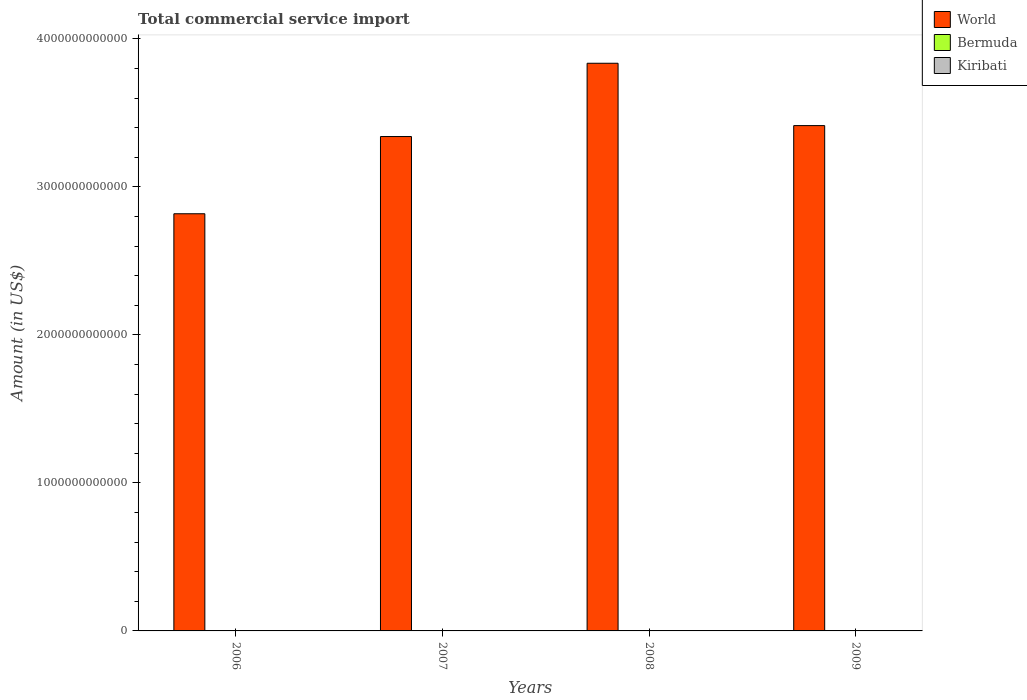How many different coloured bars are there?
Make the answer very short. 3. Are the number of bars on each tick of the X-axis equal?
Keep it short and to the point. Yes. How many bars are there on the 2nd tick from the right?
Offer a terse response. 3. What is the label of the 4th group of bars from the left?
Your response must be concise. 2009. What is the total commercial service import in Kiribati in 2009?
Give a very brief answer. 4.27e+07. Across all years, what is the maximum total commercial service import in World?
Provide a short and direct response. 3.83e+12. Across all years, what is the minimum total commercial service import in World?
Provide a succinct answer. 2.82e+12. What is the total total commercial service import in Bermuda in the graph?
Ensure brevity in your answer.  3.91e+09. What is the difference between the total commercial service import in Bermuda in 2007 and that in 2009?
Offer a very short reply. 1.24e+08. What is the difference between the total commercial service import in World in 2008 and the total commercial service import in Kiribati in 2006?
Offer a terse response. 3.83e+12. What is the average total commercial service import in Kiribati per year?
Provide a short and direct response. 4.04e+07. In the year 2008, what is the difference between the total commercial service import in Bermuda and total commercial service import in World?
Provide a succinct answer. -3.83e+12. What is the ratio of the total commercial service import in Bermuda in 2006 to that in 2008?
Make the answer very short. 0.82. Is the total commercial service import in Kiribati in 2007 less than that in 2009?
Ensure brevity in your answer.  Yes. Is the difference between the total commercial service import in Bermuda in 2006 and 2009 greater than the difference between the total commercial service import in World in 2006 and 2009?
Keep it short and to the point. Yes. What is the difference between the highest and the second highest total commercial service import in World?
Provide a succinct answer. 4.21e+11. What is the difference between the highest and the lowest total commercial service import in World?
Provide a succinct answer. 1.02e+12. In how many years, is the total commercial service import in World greater than the average total commercial service import in World taken over all years?
Keep it short and to the point. 2. Is the sum of the total commercial service import in World in 2007 and 2009 greater than the maximum total commercial service import in Kiribati across all years?
Your answer should be very brief. Yes. What does the 1st bar from the left in 2006 represents?
Your answer should be compact. World. What does the 1st bar from the right in 2007 represents?
Make the answer very short. Kiribati. Is it the case that in every year, the sum of the total commercial service import in Bermuda and total commercial service import in World is greater than the total commercial service import in Kiribati?
Your answer should be compact. Yes. Are all the bars in the graph horizontal?
Your answer should be compact. No. How many years are there in the graph?
Give a very brief answer. 4. What is the difference between two consecutive major ticks on the Y-axis?
Make the answer very short. 1.00e+12. Are the values on the major ticks of Y-axis written in scientific E-notation?
Your answer should be compact. No. Does the graph contain grids?
Offer a very short reply. No. How are the legend labels stacked?
Give a very brief answer. Vertical. What is the title of the graph?
Your answer should be very brief. Total commercial service import. Does "Vanuatu" appear as one of the legend labels in the graph?
Offer a very short reply. No. What is the Amount (in US$) in World in 2006?
Keep it short and to the point. 2.82e+12. What is the Amount (in US$) of Bermuda in 2006?
Provide a short and direct response. 8.37e+08. What is the Amount (in US$) in Kiribati in 2006?
Your answer should be very brief. 3.01e+07. What is the Amount (in US$) of World in 2007?
Ensure brevity in your answer.  3.34e+12. What is the Amount (in US$) of Bermuda in 2007?
Offer a terse response. 1.09e+09. What is the Amount (in US$) of Kiribati in 2007?
Provide a succinct answer. 4.14e+07. What is the Amount (in US$) of World in 2008?
Give a very brief answer. 3.83e+12. What is the Amount (in US$) of Bermuda in 2008?
Provide a succinct answer. 1.02e+09. What is the Amount (in US$) in Kiribati in 2008?
Provide a short and direct response. 4.74e+07. What is the Amount (in US$) of World in 2009?
Offer a very short reply. 3.41e+12. What is the Amount (in US$) in Bermuda in 2009?
Make the answer very short. 9.66e+08. What is the Amount (in US$) of Kiribati in 2009?
Your answer should be very brief. 4.27e+07. Across all years, what is the maximum Amount (in US$) of World?
Your response must be concise. 3.83e+12. Across all years, what is the maximum Amount (in US$) of Bermuda?
Offer a very short reply. 1.09e+09. Across all years, what is the maximum Amount (in US$) in Kiribati?
Ensure brevity in your answer.  4.74e+07. Across all years, what is the minimum Amount (in US$) in World?
Your response must be concise. 2.82e+12. Across all years, what is the minimum Amount (in US$) in Bermuda?
Provide a succinct answer. 8.37e+08. Across all years, what is the minimum Amount (in US$) in Kiribati?
Ensure brevity in your answer.  3.01e+07. What is the total Amount (in US$) of World in the graph?
Ensure brevity in your answer.  1.34e+13. What is the total Amount (in US$) of Bermuda in the graph?
Your answer should be very brief. 3.91e+09. What is the total Amount (in US$) of Kiribati in the graph?
Provide a short and direct response. 1.62e+08. What is the difference between the Amount (in US$) of World in 2006 and that in 2007?
Give a very brief answer. -5.22e+11. What is the difference between the Amount (in US$) in Bermuda in 2006 and that in 2007?
Provide a short and direct response. -2.54e+08. What is the difference between the Amount (in US$) in Kiribati in 2006 and that in 2007?
Offer a very short reply. -1.12e+07. What is the difference between the Amount (in US$) in World in 2006 and that in 2008?
Your response must be concise. -1.02e+12. What is the difference between the Amount (in US$) in Bermuda in 2006 and that in 2008?
Provide a short and direct response. -1.84e+08. What is the difference between the Amount (in US$) in Kiribati in 2006 and that in 2008?
Keep it short and to the point. -1.72e+07. What is the difference between the Amount (in US$) in World in 2006 and that in 2009?
Keep it short and to the point. -5.96e+11. What is the difference between the Amount (in US$) in Bermuda in 2006 and that in 2009?
Provide a succinct answer. -1.30e+08. What is the difference between the Amount (in US$) of Kiribati in 2006 and that in 2009?
Ensure brevity in your answer.  -1.26e+07. What is the difference between the Amount (in US$) in World in 2007 and that in 2008?
Your response must be concise. -4.95e+11. What is the difference between the Amount (in US$) in Bermuda in 2007 and that in 2008?
Your response must be concise. 7.03e+07. What is the difference between the Amount (in US$) in Kiribati in 2007 and that in 2008?
Offer a very short reply. -6.01e+06. What is the difference between the Amount (in US$) of World in 2007 and that in 2009?
Your response must be concise. -7.39e+1. What is the difference between the Amount (in US$) in Bermuda in 2007 and that in 2009?
Your response must be concise. 1.24e+08. What is the difference between the Amount (in US$) in Kiribati in 2007 and that in 2009?
Ensure brevity in your answer.  -1.36e+06. What is the difference between the Amount (in US$) in World in 2008 and that in 2009?
Keep it short and to the point. 4.21e+11. What is the difference between the Amount (in US$) of Bermuda in 2008 and that in 2009?
Make the answer very short. 5.42e+07. What is the difference between the Amount (in US$) in Kiribati in 2008 and that in 2009?
Your response must be concise. 4.65e+06. What is the difference between the Amount (in US$) in World in 2006 and the Amount (in US$) in Bermuda in 2007?
Your answer should be very brief. 2.82e+12. What is the difference between the Amount (in US$) of World in 2006 and the Amount (in US$) of Kiribati in 2007?
Give a very brief answer. 2.82e+12. What is the difference between the Amount (in US$) of Bermuda in 2006 and the Amount (in US$) of Kiribati in 2007?
Your response must be concise. 7.95e+08. What is the difference between the Amount (in US$) of World in 2006 and the Amount (in US$) of Bermuda in 2008?
Your answer should be compact. 2.82e+12. What is the difference between the Amount (in US$) of World in 2006 and the Amount (in US$) of Kiribati in 2008?
Ensure brevity in your answer.  2.82e+12. What is the difference between the Amount (in US$) in Bermuda in 2006 and the Amount (in US$) in Kiribati in 2008?
Your answer should be compact. 7.89e+08. What is the difference between the Amount (in US$) of World in 2006 and the Amount (in US$) of Bermuda in 2009?
Give a very brief answer. 2.82e+12. What is the difference between the Amount (in US$) in World in 2006 and the Amount (in US$) in Kiribati in 2009?
Offer a terse response. 2.82e+12. What is the difference between the Amount (in US$) in Bermuda in 2006 and the Amount (in US$) in Kiribati in 2009?
Your response must be concise. 7.94e+08. What is the difference between the Amount (in US$) of World in 2007 and the Amount (in US$) of Bermuda in 2008?
Your answer should be compact. 3.34e+12. What is the difference between the Amount (in US$) in World in 2007 and the Amount (in US$) in Kiribati in 2008?
Give a very brief answer. 3.34e+12. What is the difference between the Amount (in US$) of Bermuda in 2007 and the Amount (in US$) of Kiribati in 2008?
Keep it short and to the point. 1.04e+09. What is the difference between the Amount (in US$) of World in 2007 and the Amount (in US$) of Bermuda in 2009?
Ensure brevity in your answer.  3.34e+12. What is the difference between the Amount (in US$) of World in 2007 and the Amount (in US$) of Kiribati in 2009?
Give a very brief answer. 3.34e+12. What is the difference between the Amount (in US$) in Bermuda in 2007 and the Amount (in US$) in Kiribati in 2009?
Your answer should be very brief. 1.05e+09. What is the difference between the Amount (in US$) in World in 2008 and the Amount (in US$) in Bermuda in 2009?
Make the answer very short. 3.83e+12. What is the difference between the Amount (in US$) in World in 2008 and the Amount (in US$) in Kiribati in 2009?
Ensure brevity in your answer.  3.83e+12. What is the difference between the Amount (in US$) of Bermuda in 2008 and the Amount (in US$) of Kiribati in 2009?
Ensure brevity in your answer.  9.78e+08. What is the average Amount (in US$) in World per year?
Keep it short and to the point. 3.35e+12. What is the average Amount (in US$) of Bermuda per year?
Your answer should be compact. 9.79e+08. What is the average Amount (in US$) in Kiribati per year?
Ensure brevity in your answer.  4.04e+07. In the year 2006, what is the difference between the Amount (in US$) in World and Amount (in US$) in Bermuda?
Provide a succinct answer. 2.82e+12. In the year 2006, what is the difference between the Amount (in US$) of World and Amount (in US$) of Kiribati?
Offer a terse response. 2.82e+12. In the year 2006, what is the difference between the Amount (in US$) of Bermuda and Amount (in US$) of Kiribati?
Provide a succinct answer. 8.07e+08. In the year 2007, what is the difference between the Amount (in US$) of World and Amount (in US$) of Bermuda?
Offer a terse response. 3.34e+12. In the year 2007, what is the difference between the Amount (in US$) in World and Amount (in US$) in Kiribati?
Your answer should be very brief. 3.34e+12. In the year 2007, what is the difference between the Amount (in US$) in Bermuda and Amount (in US$) in Kiribati?
Provide a short and direct response. 1.05e+09. In the year 2008, what is the difference between the Amount (in US$) in World and Amount (in US$) in Bermuda?
Make the answer very short. 3.83e+12. In the year 2008, what is the difference between the Amount (in US$) in World and Amount (in US$) in Kiribati?
Provide a short and direct response. 3.83e+12. In the year 2008, what is the difference between the Amount (in US$) of Bermuda and Amount (in US$) of Kiribati?
Your answer should be compact. 9.73e+08. In the year 2009, what is the difference between the Amount (in US$) in World and Amount (in US$) in Bermuda?
Ensure brevity in your answer.  3.41e+12. In the year 2009, what is the difference between the Amount (in US$) in World and Amount (in US$) in Kiribati?
Make the answer very short. 3.41e+12. In the year 2009, what is the difference between the Amount (in US$) in Bermuda and Amount (in US$) in Kiribati?
Your answer should be compact. 9.24e+08. What is the ratio of the Amount (in US$) in World in 2006 to that in 2007?
Keep it short and to the point. 0.84. What is the ratio of the Amount (in US$) of Bermuda in 2006 to that in 2007?
Keep it short and to the point. 0.77. What is the ratio of the Amount (in US$) of Kiribati in 2006 to that in 2007?
Provide a short and direct response. 0.73. What is the ratio of the Amount (in US$) in World in 2006 to that in 2008?
Offer a very short reply. 0.73. What is the ratio of the Amount (in US$) of Bermuda in 2006 to that in 2008?
Your answer should be very brief. 0.82. What is the ratio of the Amount (in US$) in Kiribati in 2006 to that in 2008?
Your response must be concise. 0.64. What is the ratio of the Amount (in US$) of World in 2006 to that in 2009?
Offer a terse response. 0.83. What is the ratio of the Amount (in US$) in Bermuda in 2006 to that in 2009?
Your answer should be compact. 0.87. What is the ratio of the Amount (in US$) of Kiribati in 2006 to that in 2009?
Give a very brief answer. 0.71. What is the ratio of the Amount (in US$) of World in 2007 to that in 2008?
Ensure brevity in your answer.  0.87. What is the ratio of the Amount (in US$) of Bermuda in 2007 to that in 2008?
Offer a terse response. 1.07. What is the ratio of the Amount (in US$) in Kiribati in 2007 to that in 2008?
Ensure brevity in your answer.  0.87. What is the ratio of the Amount (in US$) in World in 2007 to that in 2009?
Your answer should be very brief. 0.98. What is the ratio of the Amount (in US$) in Bermuda in 2007 to that in 2009?
Offer a very short reply. 1.13. What is the ratio of the Amount (in US$) in Kiribati in 2007 to that in 2009?
Your answer should be compact. 0.97. What is the ratio of the Amount (in US$) in World in 2008 to that in 2009?
Make the answer very short. 1.12. What is the ratio of the Amount (in US$) of Bermuda in 2008 to that in 2009?
Ensure brevity in your answer.  1.06. What is the ratio of the Amount (in US$) of Kiribati in 2008 to that in 2009?
Offer a terse response. 1.11. What is the difference between the highest and the second highest Amount (in US$) of World?
Your answer should be compact. 4.21e+11. What is the difference between the highest and the second highest Amount (in US$) of Bermuda?
Keep it short and to the point. 7.03e+07. What is the difference between the highest and the second highest Amount (in US$) of Kiribati?
Offer a terse response. 4.65e+06. What is the difference between the highest and the lowest Amount (in US$) of World?
Your answer should be compact. 1.02e+12. What is the difference between the highest and the lowest Amount (in US$) in Bermuda?
Give a very brief answer. 2.54e+08. What is the difference between the highest and the lowest Amount (in US$) of Kiribati?
Ensure brevity in your answer.  1.72e+07. 